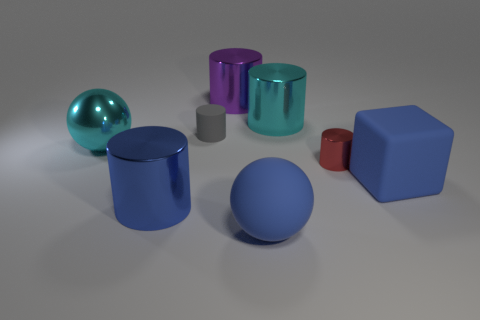Subtract all large purple cylinders. How many cylinders are left? 4 Add 2 big cyan objects. How many objects exist? 10 Subtract all red cylinders. How many cylinders are left? 4 Subtract 4 cylinders. How many cylinders are left? 1 Subtract all spheres. How many objects are left? 6 Subtract all gray balls. Subtract all purple cubes. How many balls are left? 2 Subtract all gray cylinders. How many cyan cubes are left? 0 Subtract all blue cubes. Subtract all big blue rubber spheres. How many objects are left? 6 Add 6 blue matte objects. How many blue matte objects are left? 8 Add 8 big purple cylinders. How many big purple cylinders exist? 9 